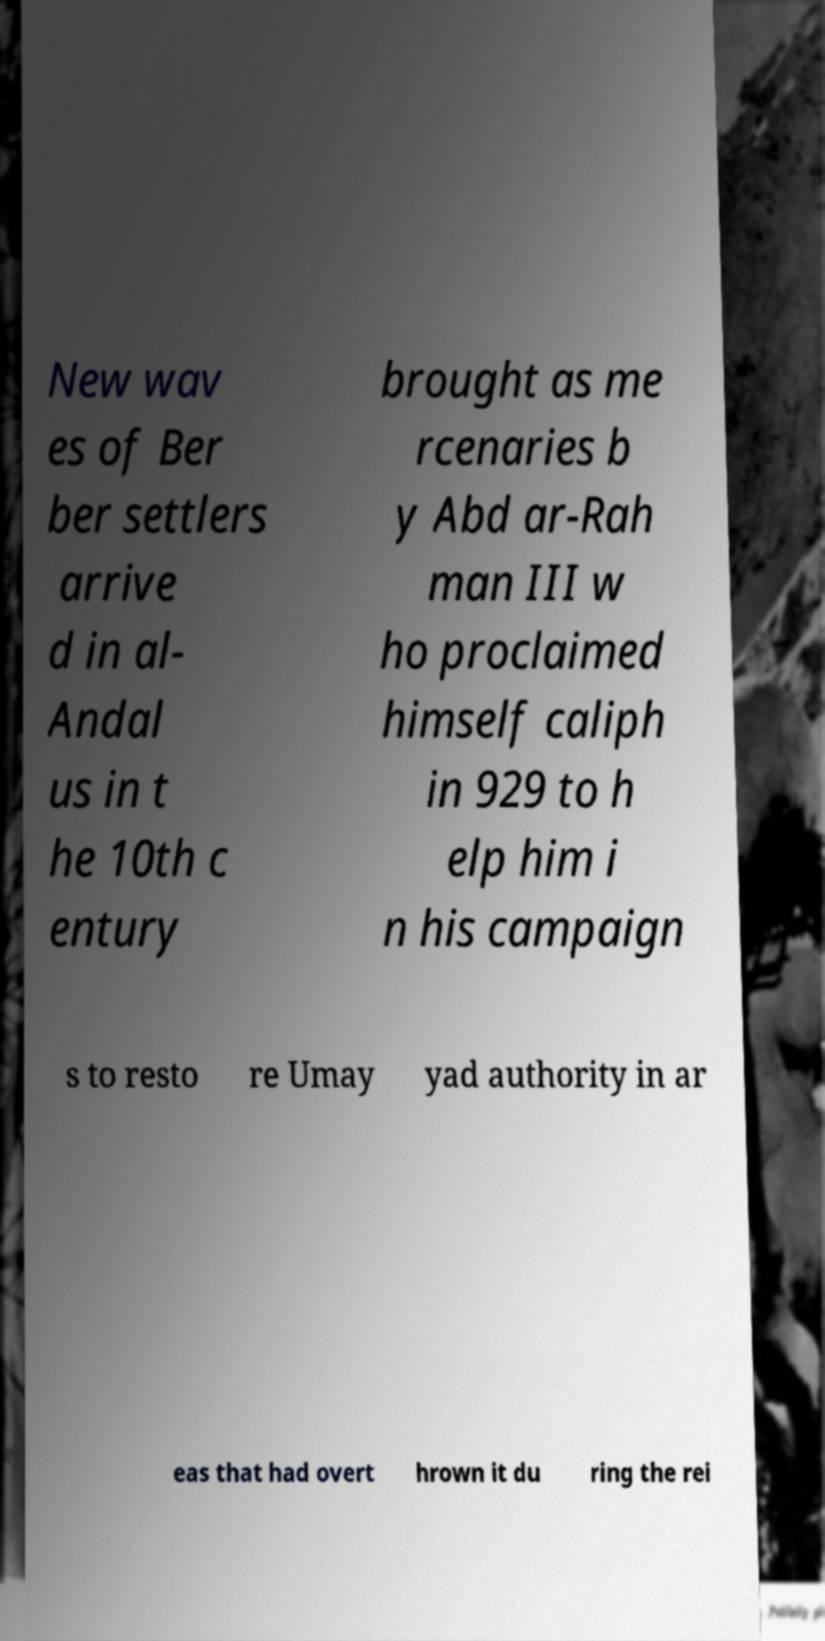There's text embedded in this image that I need extracted. Can you transcribe it verbatim? New wav es of Ber ber settlers arrive d in al- Andal us in t he 10th c entury brought as me rcenaries b y Abd ar-Rah man III w ho proclaimed himself caliph in 929 to h elp him i n his campaign s to resto re Umay yad authority in ar eas that had overt hrown it du ring the rei 